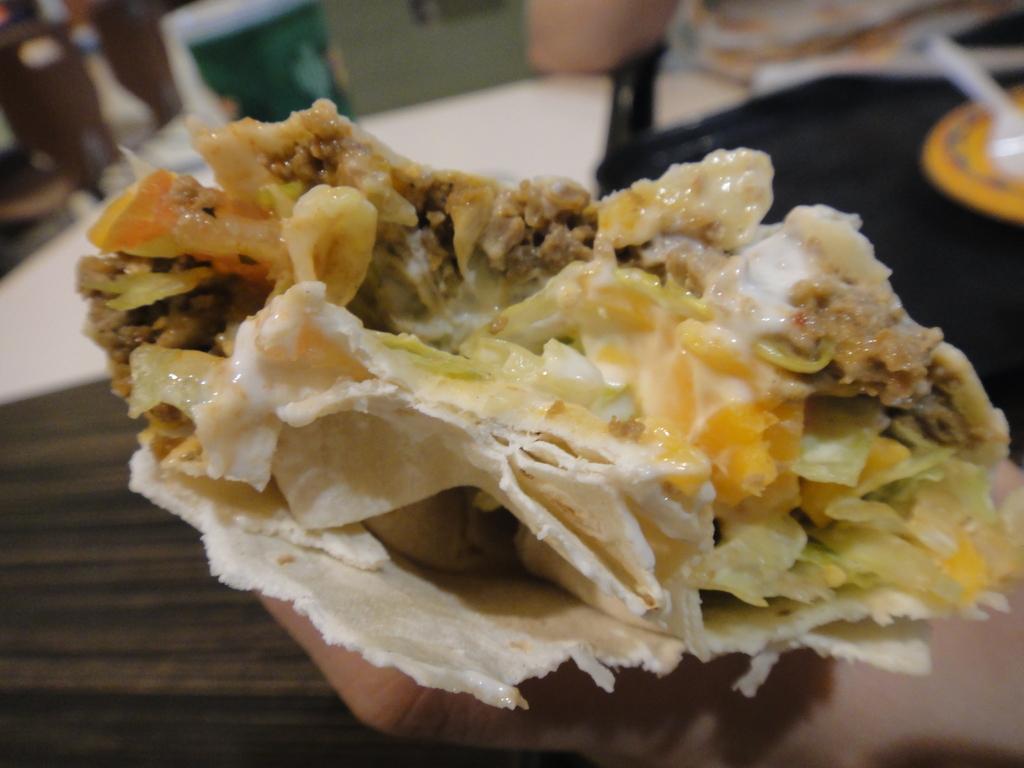Describe this image in one or two sentences. In this picture I can see the human hand is holding the food. 